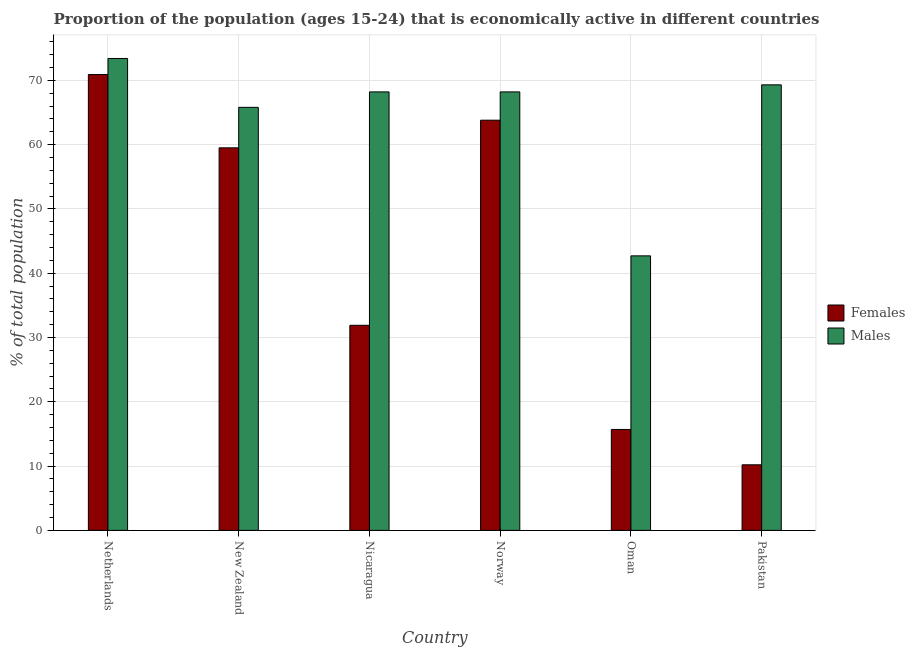Are the number of bars on each tick of the X-axis equal?
Ensure brevity in your answer.  Yes. How many bars are there on the 1st tick from the left?
Offer a terse response. 2. How many bars are there on the 4th tick from the right?
Offer a terse response. 2. What is the percentage of economically active male population in Pakistan?
Your answer should be very brief. 69.3. Across all countries, what is the maximum percentage of economically active male population?
Provide a short and direct response. 73.4. Across all countries, what is the minimum percentage of economically active male population?
Ensure brevity in your answer.  42.7. In which country was the percentage of economically active female population maximum?
Your response must be concise. Netherlands. In which country was the percentage of economically active male population minimum?
Ensure brevity in your answer.  Oman. What is the total percentage of economically active female population in the graph?
Your response must be concise. 252. What is the difference between the percentage of economically active male population in Nicaragua and that in Norway?
Ensure brevity in your answer.  0. What is the difference between the percentage of economically active female population in New Zealand and the percentage of economically active male population in Netherlands?
Your response must be concise. -13.9. What is the average percentage of economically active female population per country?
Provide a short and direct response. 42. What is the difference between the percentage of economically active female population and percentage of economically active male population in Pakistan?
Your answer should be compact. -59.1. In how many countries, is the percentage of economically active male population greater than 18 %?
Your answer should be compact. 6. What is the ratio of the percentage of economically active male population in Netherlands to that in Nicaragua?
Your answer should be very brief. 1.08. Is the difference between the percentage of economically active female population in Nicaragua and Oman greater than the difference between the percentage of economically active male population in Nicaragua and Oman?
Your answer should be compact. No. What is the difference between the highest and the second highest percentage of economically active female population?
Your answer should be compact. 7.1. What is the difference between the highest and the lowest percentage of economically active female population?
Your answer should be very brief. 60.7. In how many countries, is the percentage of economically active male population greater than the average percentage of economically active male population taken over all countries?
Provide a succinct answer. 5. Is the sum of the percentage of economically active male population in Nicaragua and Oman greater than the maximum percentage of economically active female population across all countries?
Provide a succinct answer. Yes. What does the 1st bar from the left in Netherlands represents?
Give a very brief answer. Females. What does the 1st bar from the right in Pakistan represents?
Ensure brevity in your answer.  Males. Are all the bars in the graph horizontal?
Provide a succinct answer. No. What is the difference between two consecutive major ticks on the Y-axis?
Make the answer very short. 10. Does the graph contain grids?
Keep it short and to the point. Yes. Where does the legend appear in the graph?
Give a very brief answer. Center right. How are the legend labels stacked?
Give a very brief answer. Vertical. What is the title of the graph?
Offer a very short reply. Proportion of the population (ages 15-24) that is economically active in different countries. What is the label or title of the Y-axis?
Your answer should be compact. % of total population. What is the % of total population of Females in Netherlands?
Keep it short and to the point. 70.9. What is the % of total population in Males in Netherlands?
Ensure brevity in your answer.  73.4. What is the % of total population in Females in New Zealand?
Provide a succinct answer. 59.5. What is the % of total population in Males in New Zealand?
Keep it short and to the point. 65.8. What is the % of total population of Females in Nicaragua?
Keep it short and to the point. 31.9. What is the % of total population in Males in Nicaragua?
Keep it short and to the point. 68.2. What is the % of total population of Females in Norway?
Make the answer very short. 63.8. What is the % of total population of Males in Norway?
Offer a very short reply. 68.2. What is the % of total population of Females in Oman?
Give a very brief answer. 15.7. What is the % of total population in Males in Oman?
Offer a terse response. 42.7. What is the % of total population of Females in Pakistan?
Keep it short and to the point. 10.2. What is the % of total population of Males in Pakistan?
Provide a short and direct response. 69.3. Across all countries, what is the maximum % of total population in Females?
Offer a terse response. 70.9. Across all countries, what is the maximum % of total population of Males?
Offer a terse response. 73.4. Across all countries, what is the minimum % of total population of Females?
Give a very brief answer. 10.2. Across all countries, what is the minimum % of total population of Males?
Offer a very short reply. 42.7. What is the total % of total population in Females in the graph?
Make the answer very short. 252. What is the total % of total population of Males in the graph?
Give a very brief answer. 387.6. What is the difference between the % of total population of Males in Netherlands and that in Nicaragua?
Provide a succinct answer. 5.2. What is the difference between the % of total population in Females in Netherlands and that in Norway?
Provide a succinct answer. 7.1. What is the difference between the % of total population in Males in Netherlands and that in Norway?
Provide a short and direct response. 5.2. What is the difference between the % of total population in Females in Netherlands and that in Oman?
Give a very brief answer. 55.2. What is the difference between the % of total population of Males in Netherlands and that in Oman?
Ensure brevity in your answer.  30.7. What is the difference between the % of total population of Females in Netherlands and that in Pakistan?
Your response must be concise. 60.7. What is the difference between the % of total population of Males in Netherlands and that in Pakistan?
Your answer should be compact. 4.1. What is the difference between the % of total population of Females in New Zealand and that in Nicaragua?
Ensure brevity in your answer.  27.6. What is the difference between the % of total population in Males in New Zealand and that in Norway?
Offer a very short reply. -2.4. What is the difference between the % of total population in Females in New Zealand and that in Oman?
Your response must be concise. 43.8. What is the difference between the % of total population of Males in New Zealand and that in Oman?
Keep it short and to the point. 23.1. What is the difference between the % of total population in Females in New Zealand and that in Pakistan?
Provide a succinct answer. 49.3. What is the difference between the % of total population in Males in New Zealand and that in Pakistan?
Make the answer very short. -3.5. What is the difference between the % of total population in Females in Nicaragua and that in Norway?
Give a very brief answer. -31.9. What is the difference between the % of total population of Males in Nicaragua and that in Norway?
Offer a terse response. 0. What is the difference between the % of total population in Females in Nicaragua and that in Pakistan?
Your response must be concise. 21.7. What is the difference between the % of total population in Males in Nicaragua and that in Pakistan?
Your answer should be compact. -1.1. What is the difference between the % of total population of Females in Norway and that in Oman?
Keep it short and to the point. 48.1. What is the difference between the % of total population of Females in Norway and that in Pakistan?
Give a very brief answer. 53.6. What is the difference between the % of total population in Males in Oman and that in Pakistan?
Make the answer very short. -26.6. What is the difference between the % of total population in Females in Netherlands and the % of total population in Males in New Zealand?
Keep it short and to the point. 5.1. What is the difference between the % of total population in Females in Netherlands and the % of total population in Males in Norway?
Make the answer very short. 2.7. What is the difference between the % of total population in Females in Netherlands and the % of total population in Males in Oman?
Your answer should be very brief. 28.2. What is the difference between the % of total population of Females in Netherlands and the % of total population of Males in Pakistan?
Make the answer very short. 1.6. What is the difference between the % of total population in Females in New Zealand and the % of total population in Males in Nicaragua?
Provide a short and direct response. -8.7. What is the difference between the % of total population of Females in New Zealand and the % of total population of Males in Norway?
Ensure brevity in your answer.  -8.7. What is the difference between the % of total population of Females in New Zealand and the % of total population of Males in Pakistan?
Offer a terse response. -9.8. What is the difference between the % of total population of Females in Nicaragua and the % of total population of Males in Norway?
Ensure brevity in your answer.  -36.3. What is the difference between the % of total population of Females in Nicaragua and the % of total population of Males in Oman?
Give a very brief answer. -10.8. What is the difference between the % of total population in Females in Nicaragua and the % of total population in Males in Pakistan?
Offer a very short reply. -37.4. What is the difference between the % of total population of Females in Norway and the % of total population of Males in Oman?
Your response must be concise. 21.1. What is the difference between the % of total population in Females in Oman and the % of total population in Males in Pakistan?
Your answer should be compact. -53.6. What is the average % of total population of Males per country?
Keep it short and to the point. 64.6. What is the difference between the % of total population in Females and % of total population in Males in New Zealand?
Your answer should be very brief. -6.3. What is the difference between the % of total population in Females and % of total population in Males in Nicaragua?
Your answer should be compact. -36.3. What is the difference between the % of total population in Females and % of total population in Males in Norway?
Ensure brevity in your answer.  -4.4. What is the difference between the % of total population of Females and % of total population of Males in Oman?
Keep it short and to the point. -27. What is the difference between the % of total population in Females and % of total population in Males in Pakistan?
Offer a terse response. -59.1. What is the ratio of the % of total population in Females in Netherlands to that in New Zealand?
Make the answer very short. 1.19. What is the ratio of the % of total population of Males in Netherlands to that in New Zealand?
Your answer should be very brief. 1.12. What is the ratio of the % of total population of Females in Netherlands to that in Nicaragua?
Provide a succinct answer. 2.22. What is the ratio of the % of total population in Males in Netherlands to that in Nicaragua?
Make the answer very short. 1.08. What is the ratio of the % of total population of Females in Netherlands to that in Norway?
Provide a short and direct response. 1.11. What is the ratio of the % of total population of Males in Netherlands to that in Norway?
Your response must be concise. 1.08. What is the ratio of the % of total population in Females in Netherlands to that in Oman?
Make the answer very short. 4.52. What is the ratio of the % of total population in Males in Netherlands to that in Oman?
Give a very brief answer. 1.72. What is the ratio of the % of total population of Females in Netherlands to that in Pakistan?
Your answer should be very brief. 6.95. What is the ratio of the % of total population in Males in Netherlands to that in Pakistan?
Give a very brief answer. 1.06. What is the ratio of the % of total population in Females in New Zealand to that in Nicaragua?
Provide a short and direct response. 1.87. What is the ratio of the % of total population of Males in New Zealand to that in Nicaragua?
Provide a short and direct response. 0.96. What is the ratio of the % of total population in Females in New Zealand to that in Norway?
Give a very brief answer. 0.93. What is the ratio of the % of total population of Males in New Zealand to that in Norway?
Keep it short and to the point. 0.96. What is the ratio of the % of total population of Females in New Zealand to that in Oman?
Offer a terse response. 3.79. What is the ratio of the % of total population of Males in New Zealand to that in Oman?
Offer a terse response. 1.54. What is the ratio of the % of total population in Females in New Zealand to that in Pakistan?
Give a very brief answer. 5.83. What is the ratio of the % of total population of Males in New Zealand to that in Pakistan?
Your response must be concise. 0.95. What is the ratio of the % of total population of Females in Nicaragua to that in Norway?
Your response must be concise. 0.5. What is the ratio of the % of total population in Females in Nicaragua to that in Oman?
Make the answer very short. 2.03. What is the ratio of the % of total population of Males in Nicaragua to that in Oman?
Offer a terse response. 1.6. What is the ratio of the % of total population in Females in Nicaragua to that in Pakistan?
Provide a short and direct response. 3.13. What is the ratio of the % of total population in Males in Nicaragua to that in Pakistan?
Provide a short and direct response. 0.98. What is the ratio of the % of total population in Females in Norway to that in Oman?
Make the answer very short. 4.06. What is the ratio of the % of total population in Males in Norway to that in Oman?
Provide a short and direct response. 1.6. What is the ratio of the % of total population of Females in Norway to that in Pakistan?
Give a very brief answer. 6.25. What is the ratio of the % of total population of Males in Norway to that in Pakistan?
Give a very brief answer. 0.98. What is the ratio of the % of total population of Females in Oman to that in Pakistan?
Give a very brief answer. 1.54. What is the ratio of the % of total population in Males in Oman to that in Pakistan?
Your response must be concise. 0.62. What is the difference between the highest and the second highest % of total population of Males?
Keep it short and to the point. 4.1. What is the difference between the highest and the lowest % of total population of Females?
Your answer should be compact. 60.7. What is the difference between the highest and the lowest % of total population of Males?
Offer a very short reply. 30.7. 